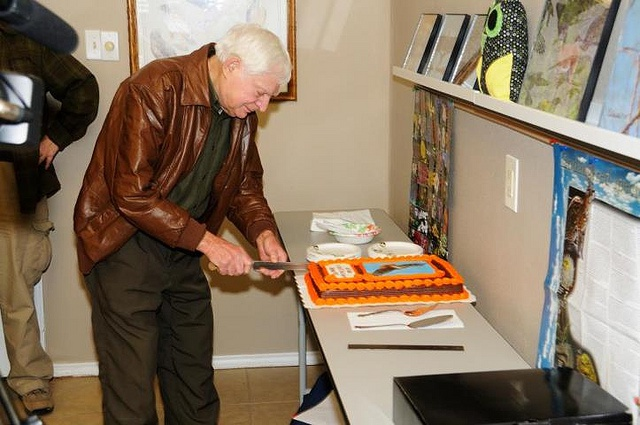Describe the objects in this image and their specific colors. I can see people in black, maroon, tan, and brown tones, people in black, olive, and gray tones, cake in black, red, orange, and brown tones, bowl in black, lightgray, beige, tan, and darkgray tones, and knife in black, gray, maroon, and tan tones in this image. 